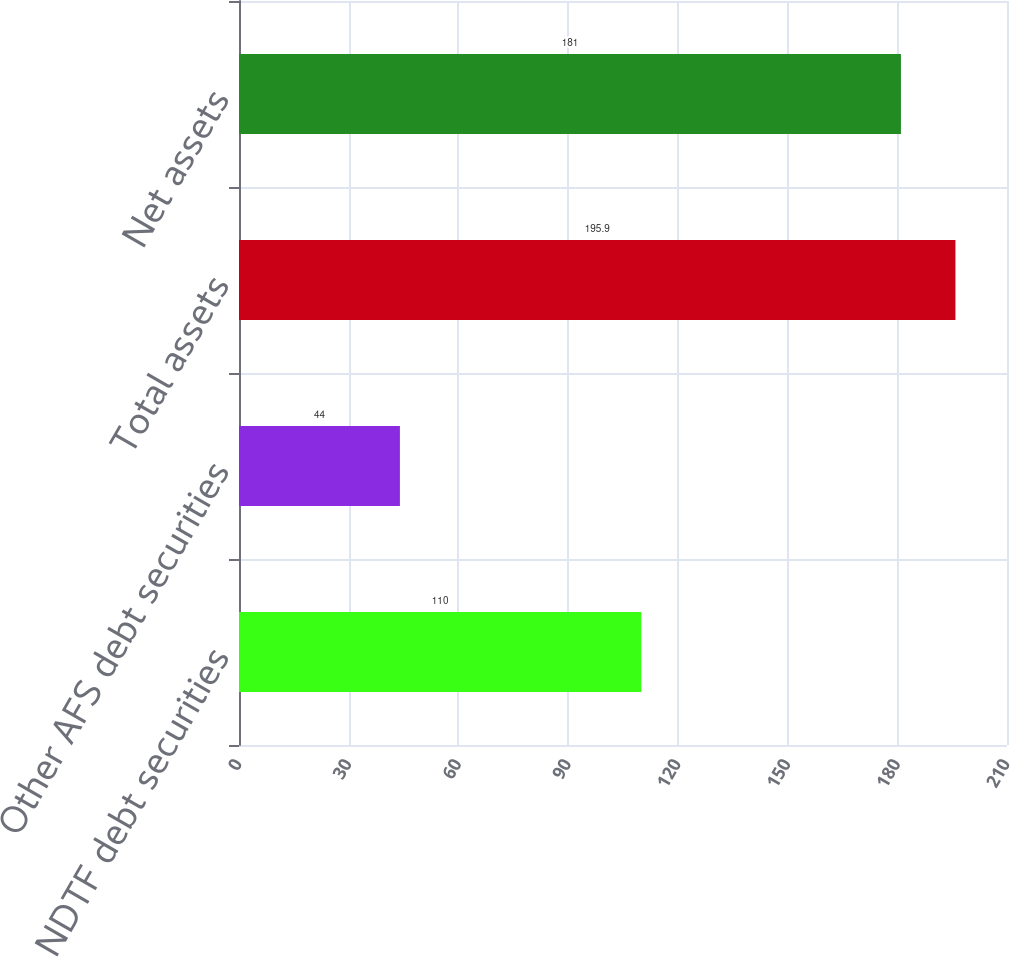<chart> <loc_0><loc_0><loc_500><loc_500><bar_chart><fcel>NDTF debt securities<fcel>Other AFS debt securities<fcel>Total assets<fcel>Net assets<nl><fcel>110<fcel>44<fcel>195.9<fcel>181<nl></chart> 